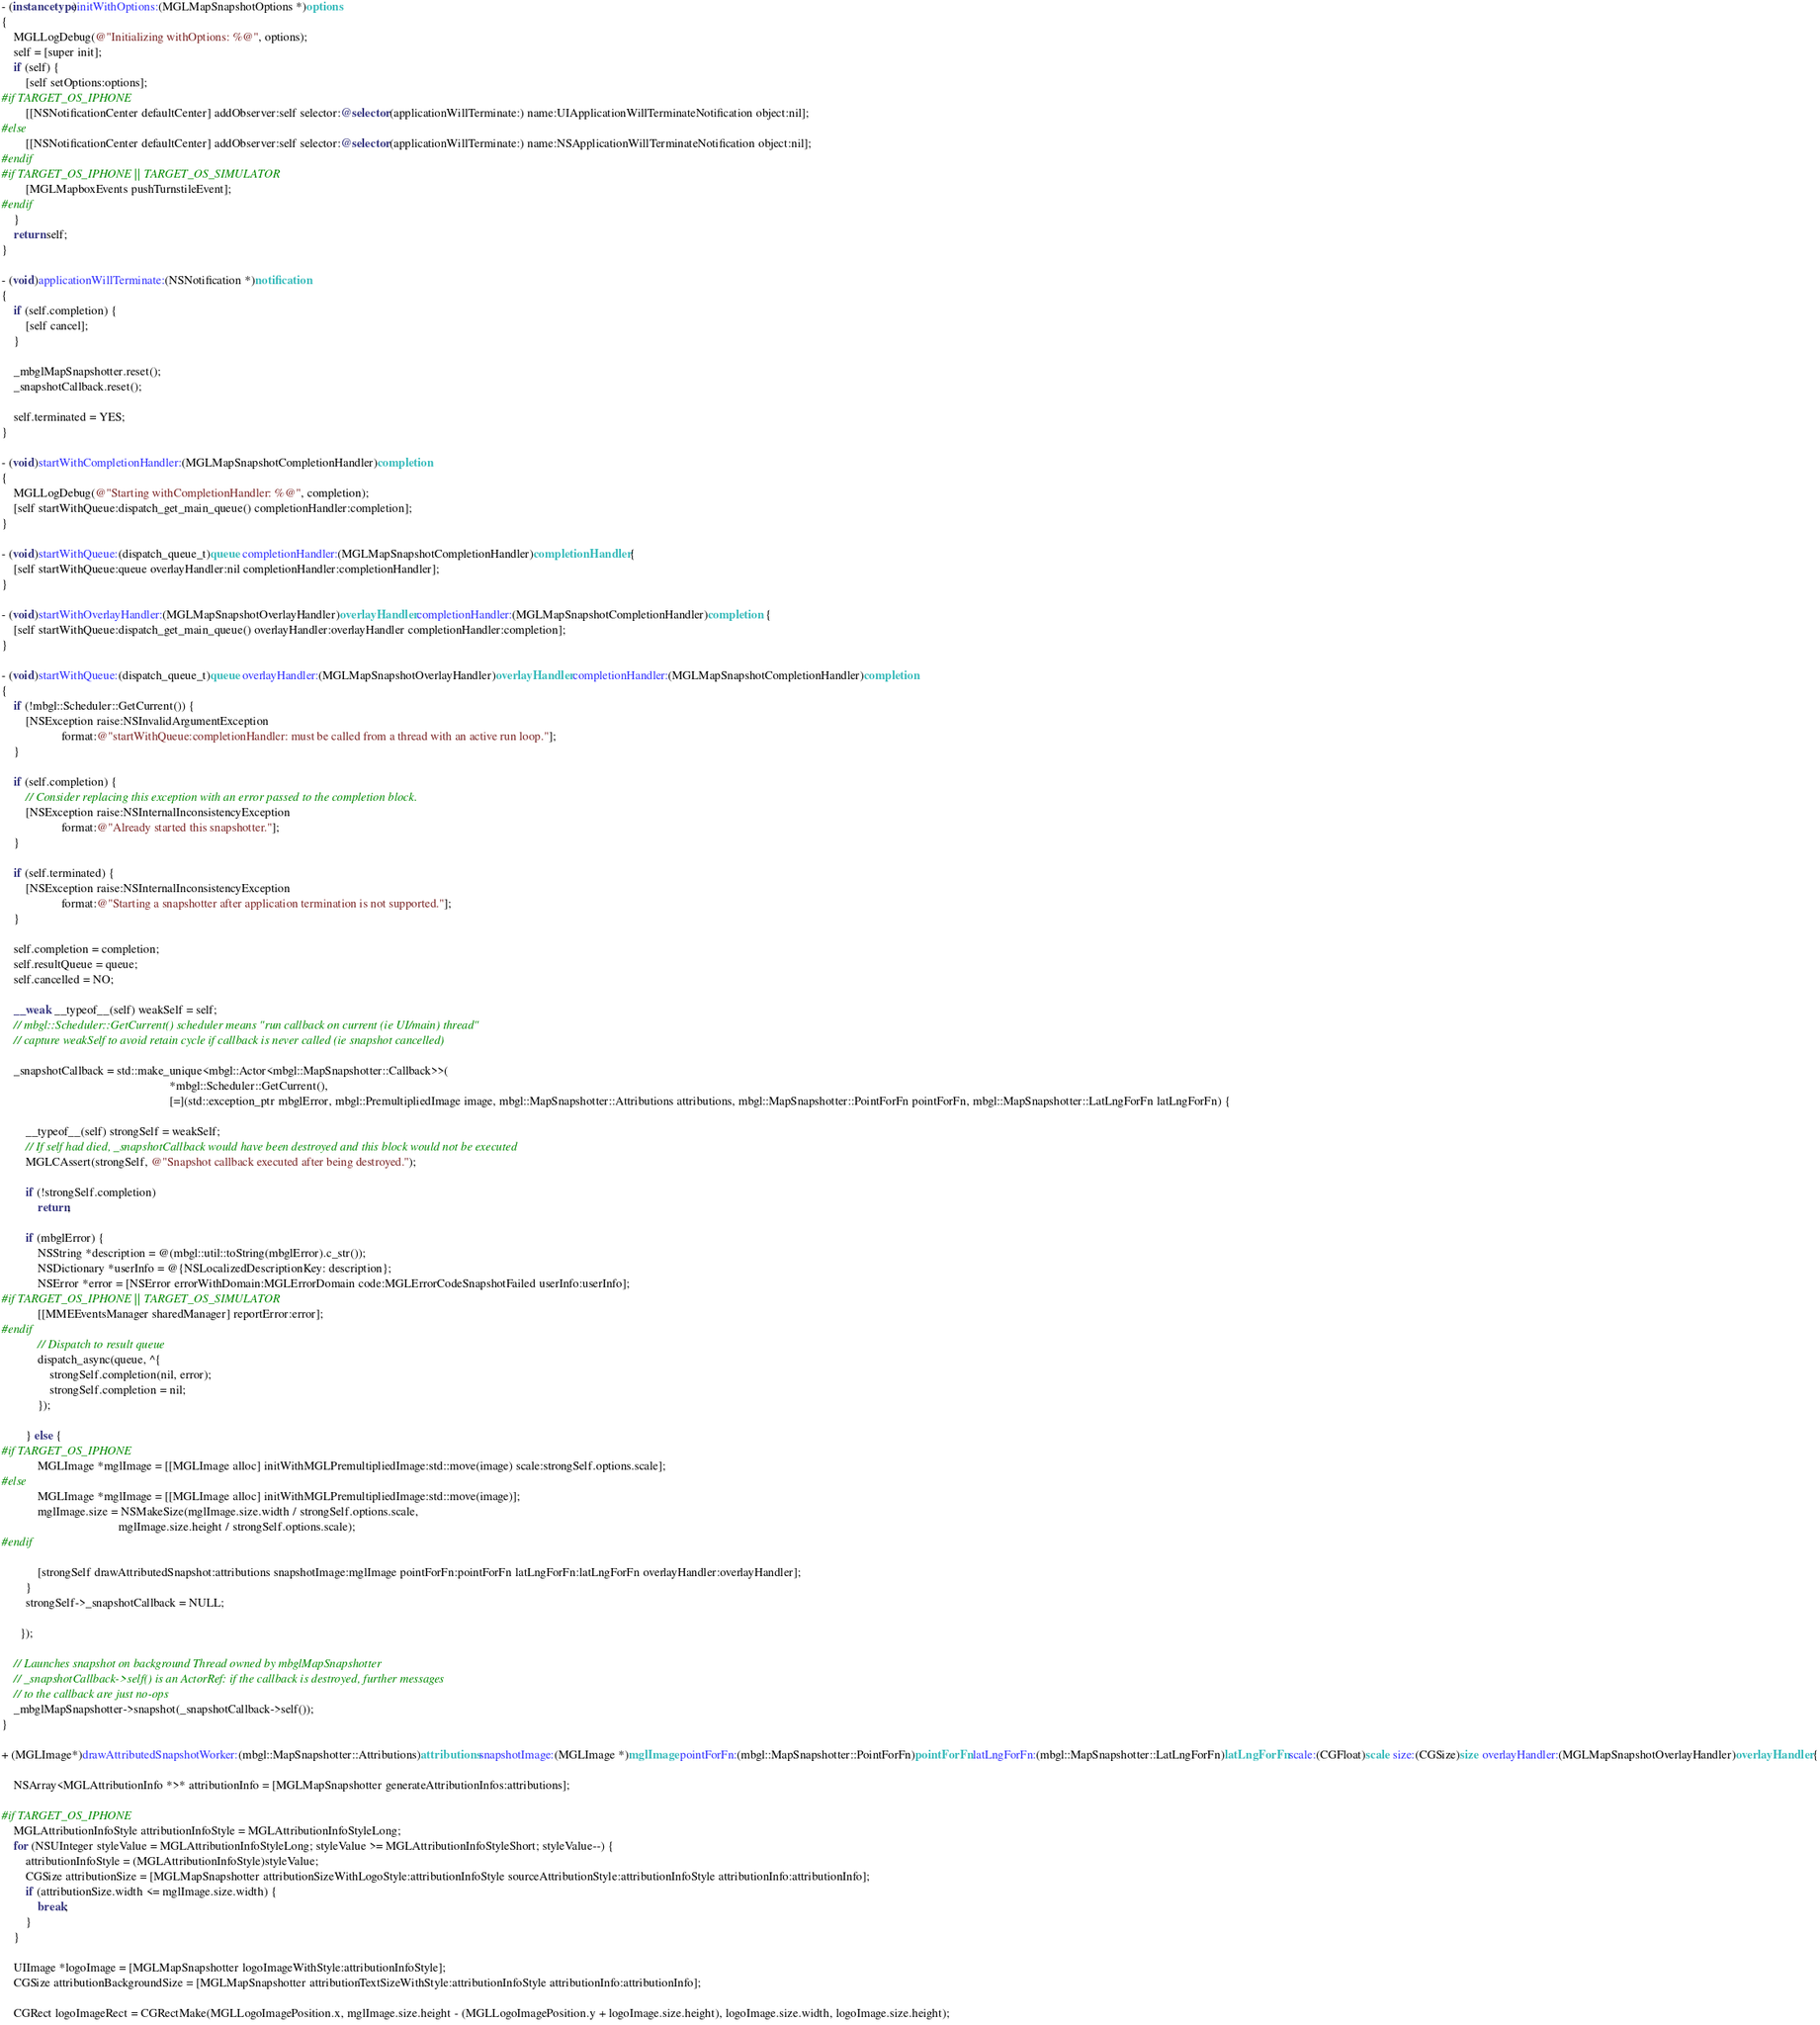<code> <loc_0><loc_0><loc_500><loc_500><_ObjectiveC_>- (instancetype)initWithOptions:(MGLMapSnapshotOptions *)options
{
    MGLLogDebug(@"Initializing withOptions: %@", options);
    self = [super init];
    if (self) {
        [self setOptions:options];
#if TARGET_OS_IPHONE
        [[NSNotificationCenter defaultCenter] addObserver:self selector:@selector(applicationWillTerminate:) name:UIApplicationWillTerminateNotification object:nil];
#else
        [[NSNotificationCenter defaultCenter] addObserver:self selector:@selector(applicationWillTerminate:) name:NSApplicationWillTerminateNotification object:nil];
#endif
#if TARGET_OS_IPHONE || TARGET_OS_SIMULATOR
        [MGLMapboxEvents pushTurnstileEvent];
#endif
    }
    return self;
}

- (void)applicationWillTerminate:(NSNotification *)notification
{
    if (self.completion) {
        [self cancel];
    }

    _mbglMapSnapshotter.reset();
    _snapshotCallback.reset();
    
    self.terminated = YES;
}

- (void)startWithCompletionHandler:(MGLMapSnapshotCompletionHandler)completion
{
    MGLLogDebug(@"Starting withCompletionHandler: %@", completion);
    [self startWithQueue:dispatch_get_main_queue() completionHandler:completion];
}

- (void)startWithQueue:(dispatch_queue_t)queue completionHandler:(MGLMapSnapshotCompletionHandler)completionHandler {
    [self startWithQueue:queue overlayHandler:nil completionHandler:completionHandler];
}

- (void)startWithOverlayHandler:(MGLMapSnapshotOverlayHandler)overlayHandler completionHandler:(MGLMapSnapshotCompletionHandler)completion {
    [self startWithQueue:dispatch_get_main_queue() overlayHandler:overlayHandler completionHandler:completion];
}

- (void)startWithQueue:(dispatch_queue_t)queue overlayHandler:(MGLMapSnapshotOverlayHandler)overlayHandler completionHandler:(MGLMapSnapshotCompletionHandler)completion
{
    if (!mbgl::Scheduler::GetCurrent()) {
        [NSException raise:NSInvalidArgumentException
                    format:@"startWithQueue:completionHandler: must be called from a thread with an active run loop."];
    }

    if (self.completion) {
        // Consider replacing this exception with an error passed to the completion block.
        [NSException raise:NSInternalInconsistencyException
                    format:@"Already started this snapshotter."];
    }

    if (self.terminated) {
        [NSException raise:NSInternalInconsistencyException
                    format:@"Starting a snapshotter after application termination is not supported."];
    }

    self.completion = completion;
    self.resultQueue = queue;
    self.cancelled = NO;

    __weak __typeof__(self) weakSelf = self;
    // mbgl::Scheduler::GetCurrent() scheduler means "run callback on current (ie UI/main) thread"
    // capture weakSelf to avoid retain cycle if callback is never called (ie snapshot cancelled)

    _snapshotCallback = std::make_unique<mbgl::Actor<mbgl::MapSnapshotter::Callback>>(
                                                        *mbgl::Scheduler::GetCurrent(),
                                                        [=](std::exception_ptr mbglError, mbgl::PremultipliedImage image, mbgl::MapSnapshotter::Attributions attributions, mbgl::MapSnapshotter::PointForFn pointForFn, mbgl::MapSnapshotter::LatLngForFn latLngForFn) {

        __typeof__(self) strongSelf = weakSelf;
        // If self had died, _snapshotCallback would have been destroyed and this block would not be executed
        MGLCAssert(strongSelf, @"Snapshot callback executed after being destroyed.");

        if (!strongSelf.completion)
            return;

        if (mbglError) {
            NSString *description = @(mbgl::util::toString(mbglError).c_str());
            NSDictionary *userInfo = @{NSLocalizedDescriptionKey: description};
            NSError *error = [NSError errorWithDomain:MGLErrorDomain code:MGLErrorCodeSnapshotFailed userInfo:userInfo];
#if TARGET_OS_IPHONE || TARGET_OS_SIMULATOR
            [[MMEEventsManager sharedManager] reportError:error];
#endif
            // Dispatch to result queue
            dispatch_async(queue, ^{
                strongSelf.completion(nil, error);
                strongSelf.completion = nil;
            });
          
        } else {
#if TARGET_OS_IPHONE
            MGLImage *mglImage = [[MGLImage alloc] initWithMGLPremultipliedImage:std::move(image) scale:strongSelf.options.scale];
#else
            MGLImage *mglImage = [[MGLImage alloc] initWithMGLPremultipliedImage:std::move(image)];
            mglImage.size = NSMakeSize(mglImage.size.width / strongSelf.options.scale,
                                       mglImage.size.height / strongSelf.options.scale);
#endif

            [strongSelf drawAttributedSnapshot:attributions snapshotImage:mglImage pointForFn:pointForFn latLngForFn:latLngForFn overlayHandler:overlayHandler];
        }
        strongSelf->_snapshotCallback = NULL;

      });

    // Launches snapshot on background Thread owned by mbglMapSnapshotter
    // _snapshotCallback->self() is an ActorRef: if the callback is destroyed, further messages
    // to the callback are just no-ops
    _mbglMapSnapshotter->snapshot(_snapshotCallback->self());
}

+ (MGLImage*)drawAttributedSnapshotWorker:(mbgl::MapSnapshotter::Attributions)attributions snapshotImage:(MGLImage *)mglImage pointForFn:(mbgl::MapSnapshotter::PointForFn)pointForFn latLngForFn:(mbgl::MapSnapshotter::LatLngForFn)latLngForFn scale:(CGFloat)scale size:(CGSize)size overlayHandler:(MGLMapSnapshotOverlayHandler)overlayHandler {

    NSArray<MGLAttributionInfo *>* attributionInfo = [MGLMapSnapshotter generateAttributionInfos:attributions];

#if TARGET_OS_IPHONE
    MGLAttributionInfoStyle attributionInfoStyle = MGLAttributionInfoStyleLong;
    for (NSUInteger styleValue = MGLAttributionInfoStyleLong; styleValue >= MGLAttributionInfoStyleShort; styleValue--) {
        attributionInfoStyle = (MGLAttributionInfoStyle)styleValue;
        CGSize attributionSize = [MGLMapSnapshotter attributionSizeWithLogoStyle:attributionInfoStyle sourceAttributionStyle:attributionInfoStyle attributionInfo:attributionInfo];
        if (attributionSize.width <= mglImage.size.width) {
            break;
        }
    }
    
    UIImage *logoImage = [MGLMapSnapshotter logoImageWithStyle:attributionInfoStyle];
    CGSize attributionBackgroundSize = [MGLMapSnapshotter attributionTextSizeWithStyle:attributionInfoStyle attributionInfo:attributionInfo];
    
    CGRect logoImageRect = CGRectMake(MGLLogoImagePosition.x, mglImage.size.height - (MGLLogoImagePosition.y + logoImage.size.height), logoImage.size.width, logoImage.size.height);</code> 